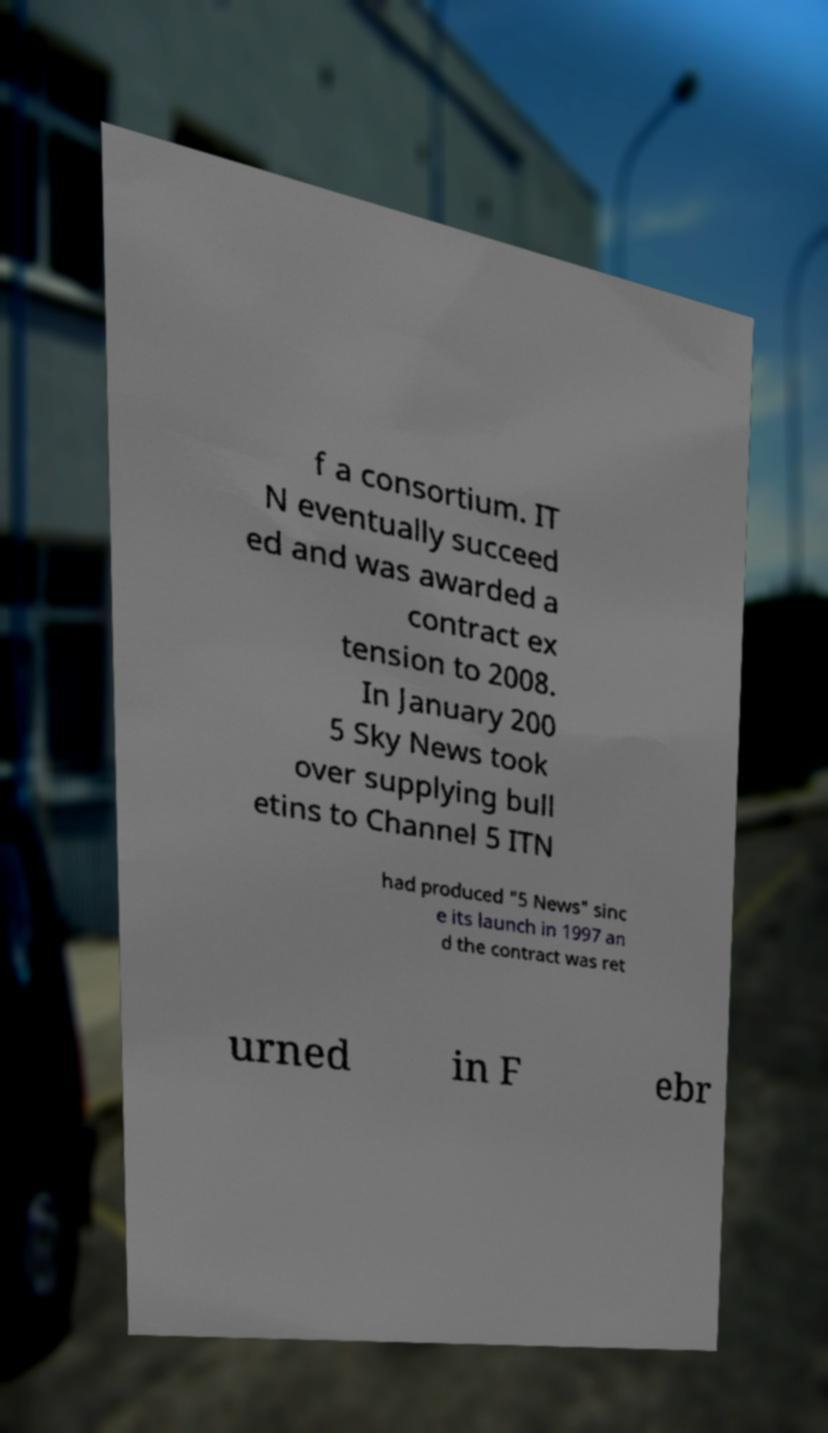There's text embedded in this image that I need extracted. Can you transcribe it verbatim? f a consortium. IT N eventually succeed ed and was awarded a contract ex tension to 2008. In January 200 5 Sky News took over supplying bull etins to Channel 5 ITN had produced "5 News" sinc e its launch in 1997 an d the contract was ret urned in F ebr 